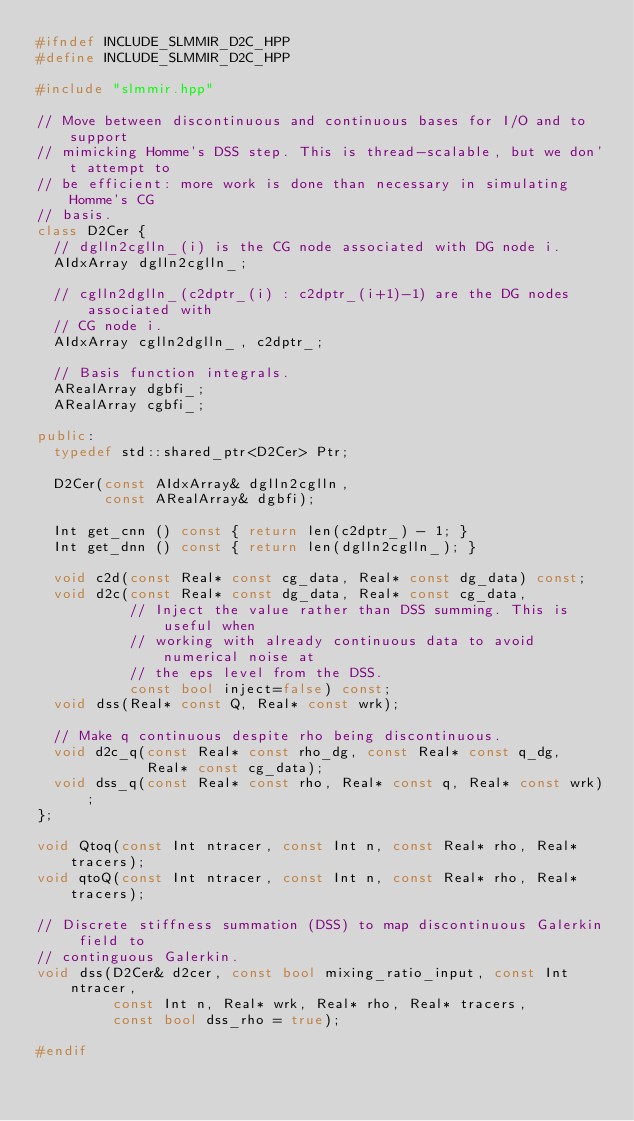<code> <loc_0><loc_0><loc_500><loc_500><_C++_>#ifndef INCLUDE_SLMMIR_D2C_HPP
#define INCLUDE_SLMMIR_D2C_HPP

#include "slmmir.hpp"

// Move between discontinuous and continuous bases for I/O and to support
// mimicking Homme's DSS step. This is thread-scalable, but we don't attempt to
// be efficient: more work is done than necessary in simulating Homme's CG
// basis.
class D2Cer {
  // dglln2cglln_(i) is the CG node associated with DG node i.
  AIdxArray dglln2cglln_;

  // cglln2dglln_(c2dptr_(i) : c2dptr_(i+1)-1) are the DG nodes associated with
  // CG node i.
  AIdxArray cglln2dglln_, c2dptr_;

  // Basis function integrals.
  ARealArray dgbfi_;
  ARealArray cgbfi_;

public:
  typedef std::shared_ptr<D2Cer> Ptr;

  D2Cer(const AIdxArray& dglln2cglln,
        const ARealArray& dgbfi);

  Int get_cnn () const { return len(c2dptr_) - 1; }
  Int get_dnn () const { return len(dglln2cglln_); }
  
  void c2d(const Real* const cg_data, Real* const dg_data) const;
  void d2c(const Real* const dg_data, Real* const cg_data,
           // Inject the value rather than DSS summing. This is useful when
           // working with already continuous data to avoid numerical noise at
           // the eps level from the DSS.
           const bool inject=false) const;
  void dss(Real* const Q, Real* const wrk);

  // Make q continuous despite rho being discontinuous.
  void d2c_q(const Real* const rho_dg, const Real* const q_dg,
             Real* const cg_data);
  void dss_q(const Real* const rho, Real* const q, Real* const wrk);
};

void Qtoq(const Int ntracer, const Int n, const Real* rho, Real* tracers);
void qtoQ(const Int ntracer, const Int n, const Real* rho, Real* tracers);

// Discrete stiffness summation (DSS) to map discontinuous Galerkin field to
// continguous Galerkin.
void dss(D2Cer& d2cer, const bool mixing_ratio_input, const Int ntracer,
         const Int n, Real* wrk, Real* rho, Real* tracers,
         const bool dss_rho = true);

#endif
</code> 